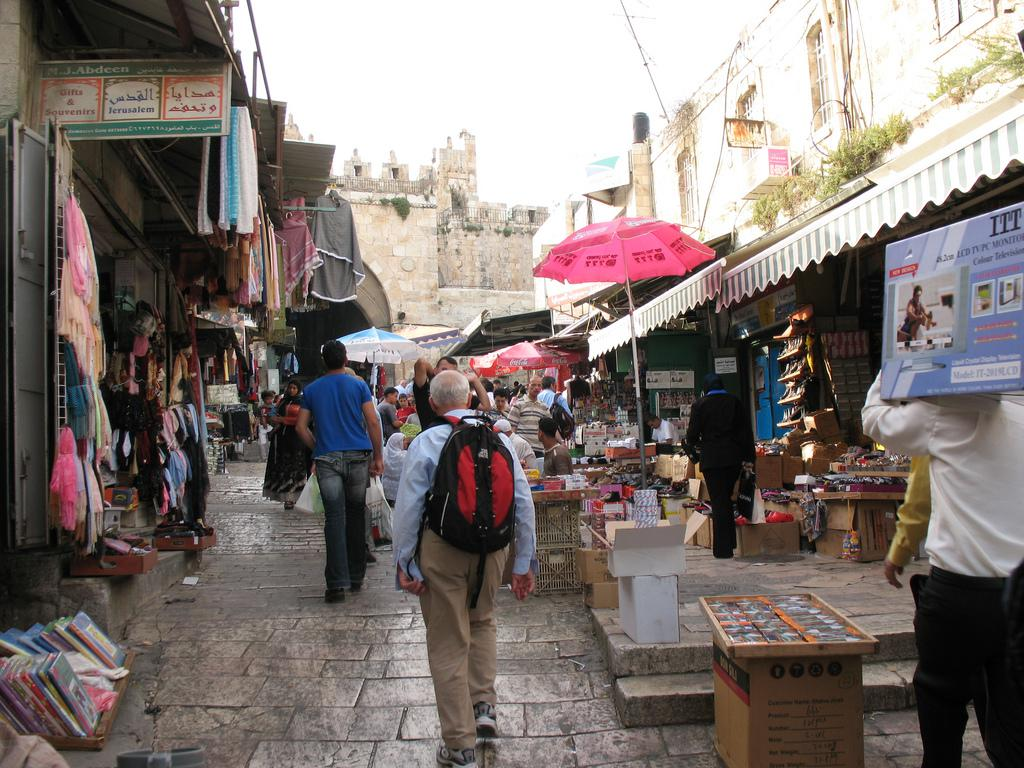Question: what color is the umbrella?
Choices:
A. Purple.
B. Black.
C. Pink.
D. Yellow.
Answer with the letter. Answer: C Question: what type of street is it?
Choices:
A. One-Way.
B. Asphalt.
C. Cobblestone.
D. Concrete.
Answer with the letter. Answer: C Question: what is the man carrying on his shoulder?
Choices:
A. A large box.
B. Backpack.
C. Fishing Pole.
D. Gun.
Answer with the letter. Answer: A Question: why might someone come here?
Choices:
A. To shop.
B. To people watch.
C. To read.
D. To sleep.
Answer with the letter. Answer: A Question: where was this picture taken?
Choices:
A. A basketball game.
B. A concert.
C. An outdoor market.
D. A picnic.
Answer with the letter. Answer: C Question: what does the store on the left sell?
Choices:
A. Bikes.
B. Shoes.
C. Clothing.
D. Sporting Goods.
Answer with the letter. Answer: C Question: what are the people in the picture doing?
Choices:
A. Riding bikes.
B. Riding on skateboards.
C. Riding on scooters.
D. Walking down a street.
Answer with the letter. Answer: D Question: what is on this street?
Choices:
A. A dog groomer.
B. An antique store.
C. An aquarium.
D. Unique boutiques.
Answer with the letter. Answer: D Question: how is the umbrella?
Choices:
A. Closed.
B. Broken.
C. Open.
D. Fixed.
Answer with the letter. Answer: C Question: who is carrying a large box?
Choices:
A. A woman.
B. A man.
C. A child.
D. A moving man.
Answer with the letter. Answer: B Question: where do the signs hang?
Choices:
A. In the hall way.
B. On the street.
C. Above the walkway.
D. In town.
Answer with the letter. Answer: C Question: where does the merchandies sit?
Choices:
A. On a shelf.
B. The ground.
C. In a case.
D. On a desk.
Answer with the letter. Answer: B Question: who walks down the street?
Choices:
A. A man.
B. A woman.
C. A dog.
D. A cat.
Answer with the letter. Answer: A Question: what does the shop have hanging out front?
Choices:
A. Clothes.
B. A sign.
C. A poster.
D. A flag.
Answer with the letter. Answer: A Question: what paves the pathway?
Choices:
A. Pavement.
B. Bricks.
C. Concrete.
D. Gravel.
Answer with the letter. Answer: B Question: what do the bricks pave?
Choices:
A. Garden bed.
B. Pathway.
C. Driveway.
D. Walk way.
Answer with the letter. Answer: B Question: what does the man wear?
Choices:
A. Shirt.
B. Sneakers.
C. Pants.
D. Tie.
Answer with the letter. Answer: B Question: who is wearing sneakers?
Choices:
A. The woman.
B. The little boy.
C. The little girl.
D. The man.
Answer with the letter. Answer: D Question: what are the people crowding?
Choices:
A. The walkway.
B. The door.
C. The exit.
D. The bathroom.
Answer with the letter. Answer: A Question: what does the gray haired man carry?
Choices:
A. A cane.
B. A water bottle.
C. Money.
D. A backpack.
Answer with the letter. Answer: D Question: who carries a backpack?
Choices:
A. A gray haired man.
B. A young man.
C. A child.
D. A woman.
Answer with the letter. Answer: A Question: what blocks a man's face?
Choices:
A. His hands.
B. A woman.
C. A newspaper.
D. A large box.
Answer with the letter. Answer: D Question: how does the building look?
Choices:
A. Distressed.
B. Ancient.
C. New.
D. Clean.
Answer with the letter. Answer: B Question: where is the umbrella?
Choices:
A. In a womans' hand.
B. On the floor.
C. On the right.
D. The middle.
Answer with the letter. Answer: D Question: how are people dressed?
Choices:
A. Like clowns.
B. White tie.
C. In swim suits.
D. In a variety of styles.
Answer with the letter. Answer: D Question: what grows on the awning of some buildings?
Choices:
A. Some greenery.
B. Ivy.
C. Fungus.
D. Honeysuckle.
Answer with the letter. Answer: A 